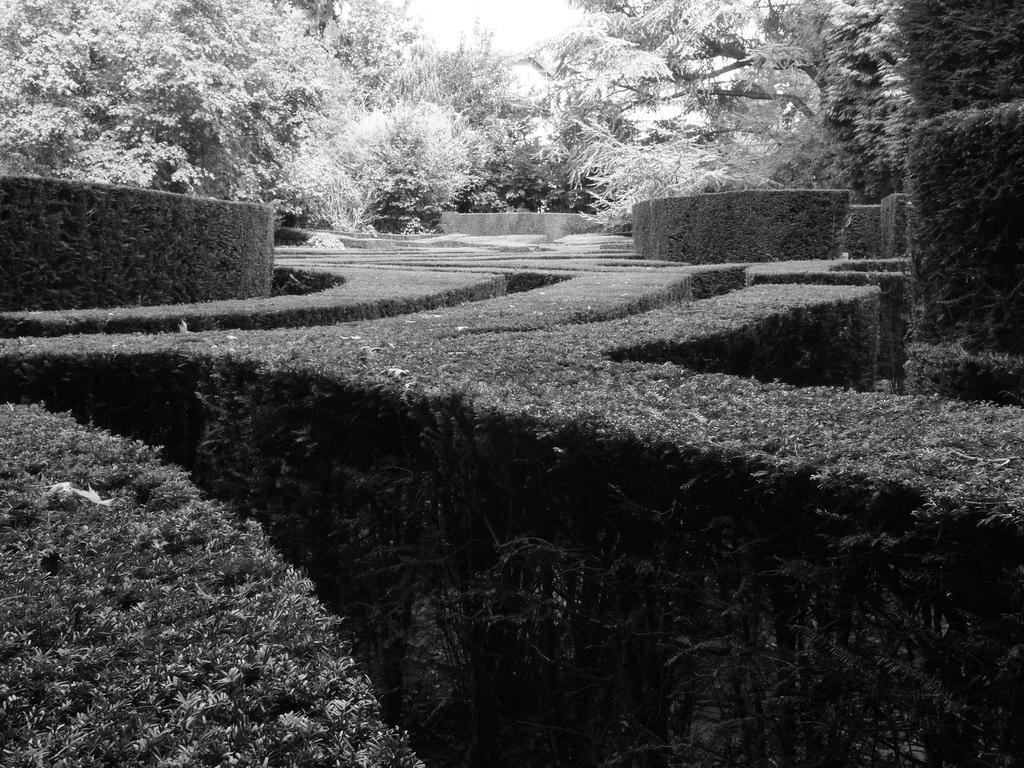Could you give a brief overview of what you see in this image? This is a black and white and here we can see hedges and trees. 